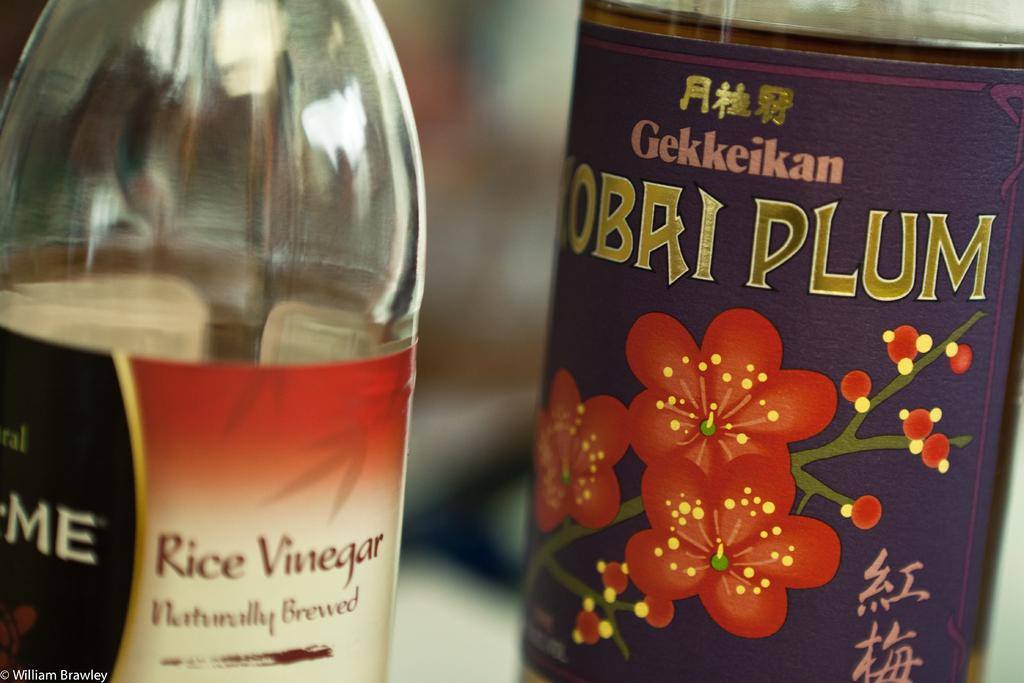Provide a one-sentence caption for the provided image. A bottle of rice vinegar and plum wine sit side by side. 